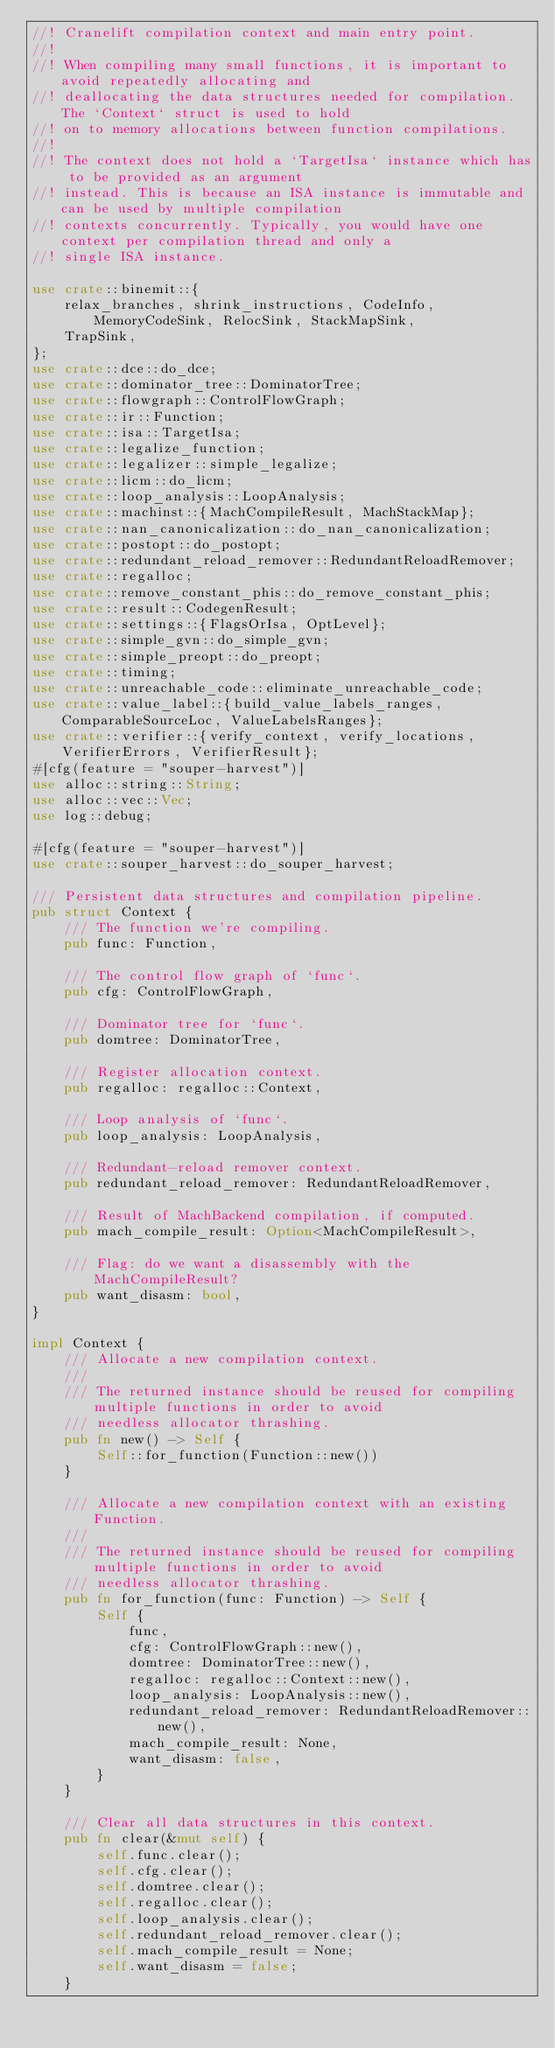Convert code to text. <code><loc_0><loc_0><loc_500><loc_500><_Rust_>//! Cranelift compilation context and main entry point.
//!
//! When compiling many small functions, it is important to avoid repeatedly allocating and
//! deallocating the data structures needed for compilation. The `Context` struct is used to hold
//! on to memory allocations between function compilations.
//!
//! The context does not hold a `TargetIsa` instance which has to be provided as an argument
//! instead. This is because an ISA instance is immutable and can be used by multiple compilation
//! contexts concurrently. Typically, you would have one context per compilation thread and only a
//! single ISA instance.

use crate::binemit::{
    relax_branches, shrink_instructions, CodeInfo, MemoryCodeSink, RelocSink, StackMapSink,
    TrapSink,
};
use crate::dce::do_dce;
use crate::dominator_tree::DominatorTree;
use crate::flowgraph::ControlFlowGraph;
use crate::ir::Function;
use crate::isa::TargetIsa;
use crate::legalize_function;
use crate::legalizer::simple_legalize;
use crate::licm::do_licm;
use crate::loop_analysis::LoopAnalysis;
use crate::machinst::{MachCompileResult, MachStackMap};
use crate::nan_canonicalization::do_nan_canonicalization;
use crate::postopt::do_postopt;
use crate::redundant_reload_remover::RedundantReloadRemover;
use crate::regalloc;
use crate::remove_constant_phis::do_remove_constant_phis;
use crate::result::CodegenResult;
use crate::settings::{FlagsOrIsa, OptLevel};
use crate::simple_gvn::do_simple_gvn;
use crate::simple_preopt::do_preopt;
use crate::timing;
use crate::unreachable_code::eliminate_unreachable_code;
use crate::value_label::{build_value_labels_ranges, ComparableSourceLoc, ValueLabelsRanges};
use crate::verifier::{verify_context, verify_locations, VerifierErrors, VerifierResult};
#[cfg(feature = "souper-harvest")]
use alloc::string::String;
use alloc::vec::Vec;
use log::debug;

#[cfg(feature = "souper-harvest")]
use crate::souper_harvest::do_souper_harvest;

/// Persistent data structures and compilation pipeline.
pub struct Context {
    /// The function we're compiling.
    pub func: Function,

    /// The control flow graph of `func`.
    pub cfg: ControlFlowGraph,

    /// Dominator tree for `func`.
    pub domtree: DominatorTree,

    /// Register allocation context.
    pub regalloc: regalloc::Context,

    /// Loop analysis of `func`.
    pub loop_analysis: LoopAnalysis,

    /// Redundant-reload remover context.
    pub redundant_reload_remover: RedundantReloadRemover,

    /// Result of MachBackend compilation, if computed.
    pub mach_compile_result: Option<MachCompileResult>,

    /// Flag: do we want a disassembly with the MachCompileResult?
    pub want_disasm: bool,
}

impl Context {
    /// Allocate a new compilation context.
    ///
    /// The returned instance should be reused for compiling multiple functions in order to avoid
    /// needless allocator thrashing.
    pub fn new() -> Self {
        Self::for_function(Function::new())
    }

    /// Allocate a new compilation context with an existing Function.
    ///
    /// The returned instance should be reused for compiling multiple functions in order to avoid
    /// needless allocator thrashing.
    pub fn for_function(func: Function) -> Self {
        Self {
            func,
            cfg: ControlFlowGraph::new(),
            domtree: DominatorTree::new(),
            regalloc: regalloc::Context::new(),
            loop_analysis: LoopAnalysis::new(),
            redundant_reload_remover: RedundantReloadRemover::new(),
            mach_compile_result: None,
            want_disasm: false,
        }
    }

    /// Clear all data structures in this context.
    pub fn clear(&mut self) {
        self.func.clear();
        self.cfg.clear();
        self.domtree.clear();
        self.regalloc.clear();
        self.loop_analysis.clear();
        self.redundant_reload_remover.clear();
        self.mach_compile_result = None;
        self.want_disasm = false;
    }
</code> 